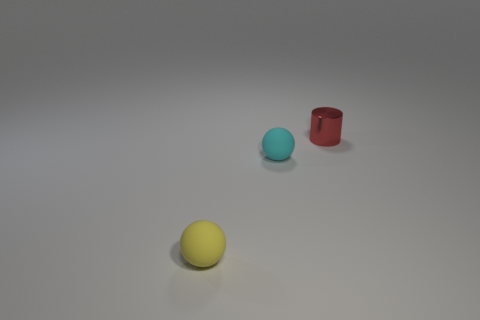Add 3 big yellow matte things. How many objects exist? 6 Subtract all cyan spheres. How many spheres are left? 1 Subtract all cylinders. How many objects are left? 2 Subtract all red spheres. Subtract all gray cubes. How many spheres are left? 2 Subtract all green cylinders. How many green balls are left? 0 Subtract all small spheres. Subtract all cyan rubber objects. How many objects are left? 0 Add 3 yellow things. How many yellow things are left? 4 Add 2 gray rubber spheres. How many gray rubber spheres exist? 2 Subtract 0 green cubes. How many objects are left? 3 Subtract 1 balls. How many balls are left? 1 